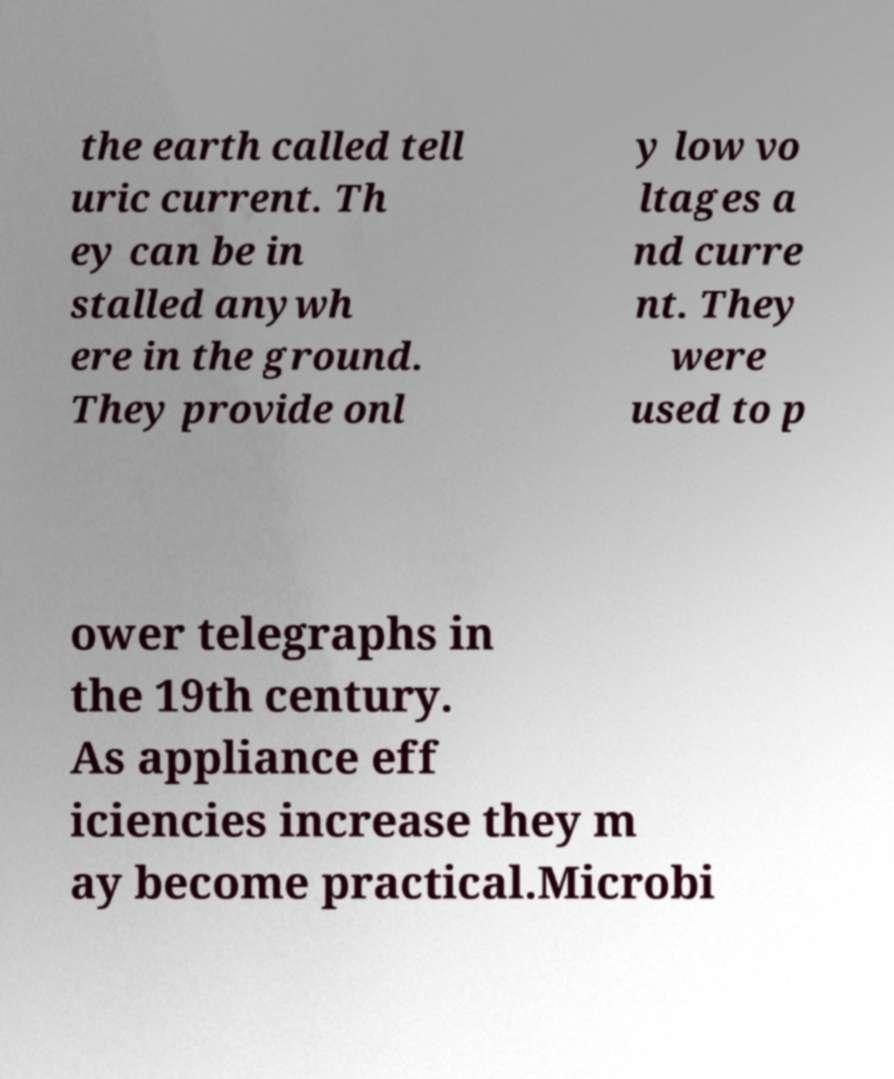Please read and relay the text visible in this image. What does it say? the earth called tell uric current. Th ey can be in stalled anywh ere in the ground. They provide onl y low vo ltages a nd curre nt. They were used to p ower telegraphs in the 19th century. As appliance eff iciencies increase they m ay become practical.Microbi 